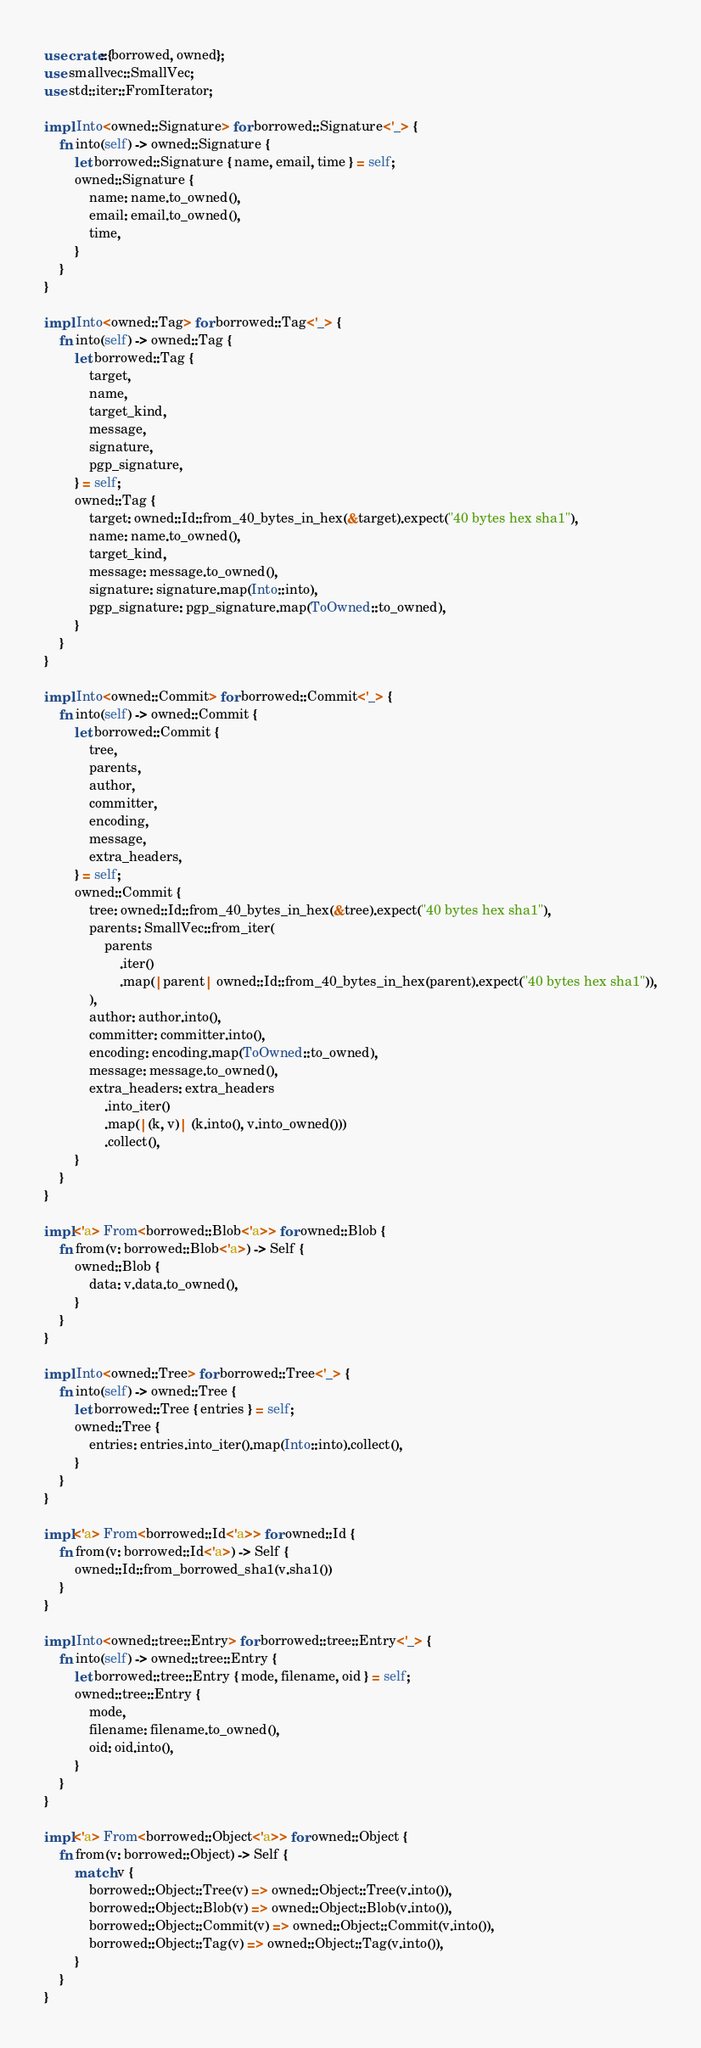Convert code to text. <code><loc_0><loc_0><loc_500><loc_500><_Rust_>use crate::{borrowed, owned};
use smallvec::SmallVec;
use std::iter::FromIterator;

impl Into<owned::Signature> for borrowed::Signature<'_> {
    fn into(self) -> owned::Signature {
        let borrowed::Signature { name, email, time } = self;
        owned::Signature {
            name: name.to_owned(),
            email: email.to_owned(),
            time,
        }
    }
}

impl Into<owned::Tag> for borrowed::Tag<'_> {
    fn into(self) -> owned::Tag {
        let borrowed::Tag {
            target,
            name,
            target_kind,
            message,
            signature,
            pgp_signature,
        } = self;
        owned::Tag {
            target: owned::Id::from_40_bytes_in_hex(&target).expect("40 bytes hex sha1"),
            name: name.to_owned(),
            target_kind,
            message: message.to_owned(),
            signature: signature.map(Into::into),
            pgp_signature: pgp_signature.map(ToOwned::to_owned),
        }
    }
}

impl Into<owned::Commit> for borrowed::Commit<'_> {
    fn into(self) -> owned::Commit {
        let borrowed::Commit {
            tree,
            parents,
            author,
            committer,
            encoding,
            message,
            extra_headers,
        } = self;
        owned::Commit {
            tree: owned::Id::from_40_bytes_in_hex(&tree).expect("40 bytes hex sha1"),
            parents: SmallVec::from_iter(
                parents
                    .iter()
                    .map(|parent| owned::Id::from_40_bytes_in_hex(parent).expect("40 bytes hex sha1")),
            ),
            author: author.into(),
            committer: committer.into(),
            encoding: encoding.map(ToOwned::to_owned),
            message: message.to_owned(),
            extra_headers: extra_headers
                .into_iter()
                .map(|(k, v)| (k.into(), v.into_owned()))
                .collect(),
        }
    }
}

impl<'a> From<borrowed::Blob<'a>> for owned::Blob {
    fn from(v: borrowed::Blob<'a>) -> Self {
        owned::Blob {
            data: v.data.to_owned(),
        }
    }
}

impl Into<owned::Tree> for borrowed::Tree<'_> {
    fn into(self) -> owned::Tree {
        let borrowed::Tree { entries } = self;
        owned::Tree {
            entries: entries.into_iter().map(Into::into).collect(),
        }
    }
}

impl<'a> From<borrowed::Id<'a>> for owned::Id {
    fn from(v: borrowed::Id<'a>) -> Self {
        owned::Id::from_borrowed_sha1(v.sha1())
    }
}

impl Into<owned::tree::Entry> for borrowed::tree::Entry<'_> {
    fn into(self) -> owned::tree::Entry {
        let borrowed::tree::Entry { mode, filename, oid } = self;
        owned::tree::Entry {
            mode,
            filename: filename.to_owned(),
            oid: oid.into(),
        }
    }
}

impl<'a> From<borrowed::Object<'a>> for owned::Object {
    fn from(v: borrowed::Object) -> Self {
        match v {
            borrowed::Object::Tree(v) => owned::Object::Tree(v.into()),
            borrowed::Object::Blob(v) => owned::Object::Blob(v.into()),
            borrowed::Object::Commit(v) => owned::Object::Commit(v.into()),
            borrowed::Object::Tag(v) => owned::Object::Tag(v.into()),
        }
    }
}
</code> 